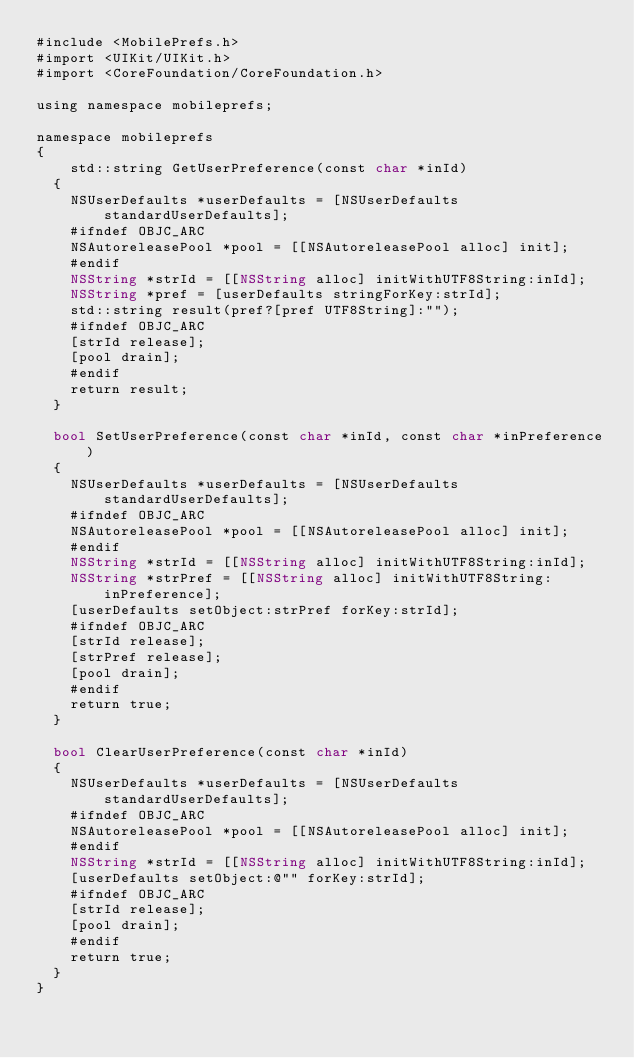<code> <loc_0><loc_0><loc_500><loc_500><_ObjectiveC_>#include <MobilePrefs.h>
#import <UIKit/UIKit.h>
#import <CoreFoundation/CoreFoundation.h>

using namespace mobileprefs;

namespace mobileprefs 
{
    std::string GetUserPreference(const char *inId)
	{
		NSUserDefaults *userDefaults = [NSUserDefaults standardUserDefaults];
		#ifndef OBJC_ARC
		NSAutoreleasePool *pool = [[NSAutoreleasePool alloc] init];
		#endif
		NSString *strId = [[NSString alloc] initWithUTF8String:inId];
		NSString *pref = [userDefaults stringForKey:strId];
		std::string result(pref?[pref UTF8String]:"");
		#ifndef OBJC_ARC
		[strId release];
		[pool drain];
		#endif
		return result;
	}

	bool SetUserPreference(const char *inId, const char *inPreference)
	{
		NSUserDefaults *userDefaults = [NSUserDefaults standardUserDefaults];
		#ifndef OBJC_ARC
		NSAutoreleasePool *pool = [[NSAutoreleasePool alloc] init];
		#endif
		NSString *strId = [[NSString alloc] initWithUTF8String:inId];
		NSString *strPref = [[NSString alloc] initWithUTF8String:inPreference];
		[userDefaults setObject:strPref forKey:strId];
		#ifndef OBJC_ARC
		[strId release];
		[strPref release];
		[pool drain];
		#endif
		return true;
	}

	bool ClearUserPreference(const char *inId)
	{
		NSUserDefaults *userDefaults = [NSUserDefaults standardUserDefaults];
		#ifndef OBJC_ARC
		NSAutoreleasePool *pool = [[NSAutoreleasePool alloc] init];
		#endif
		NSString *strId = [[NSString alloc] initWithUTF8String:inId];
		[userDefaults setObject:@"" forKey:strId];
		#ifndef OBJC_ARC
		[strId release];
		[pool drain];
		#endif
		return true;
	}
}</code> 